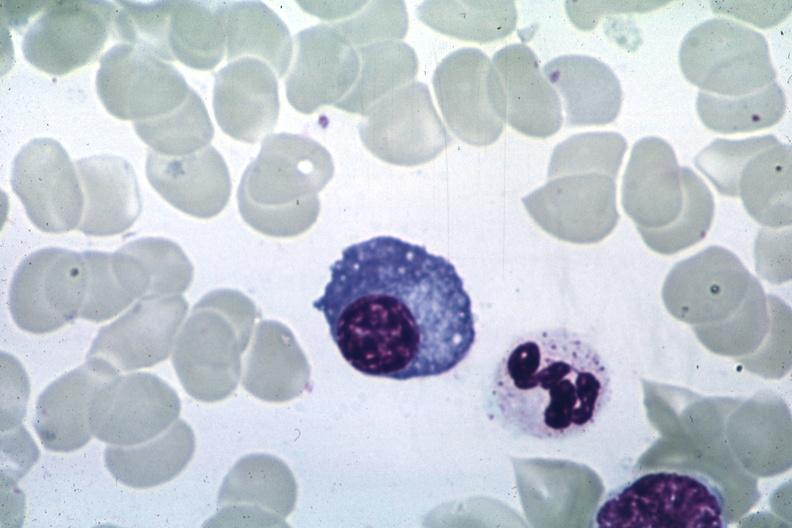s whipples disease present?
Answer the question using a single word or phrase. No 